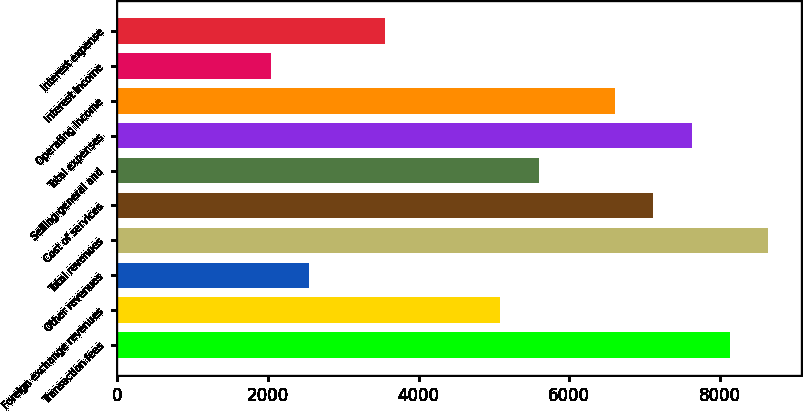Convert chart. <chart><loc_0><loc_0><loc_500><loc_500><bar_chart><fcel>Transaction fees<fcel>Foreign exchange revenues<fcel>Other revenues<fcel>Total revenues<fcel>Cost of services<fcel>Selling general and<fcel>Total expenses<fcel>Operating income<fcel>Interest income<fcel>Interest expense<nl><fcel>8133.7<fcel>5083.6<fcel>2541.85<fcel>8642.05<fcel>7117<fcel>5591.95<fcel>7625.35<fcel>6608.65<fcel>2033.5<fcel>3558.55<nl></chart> 